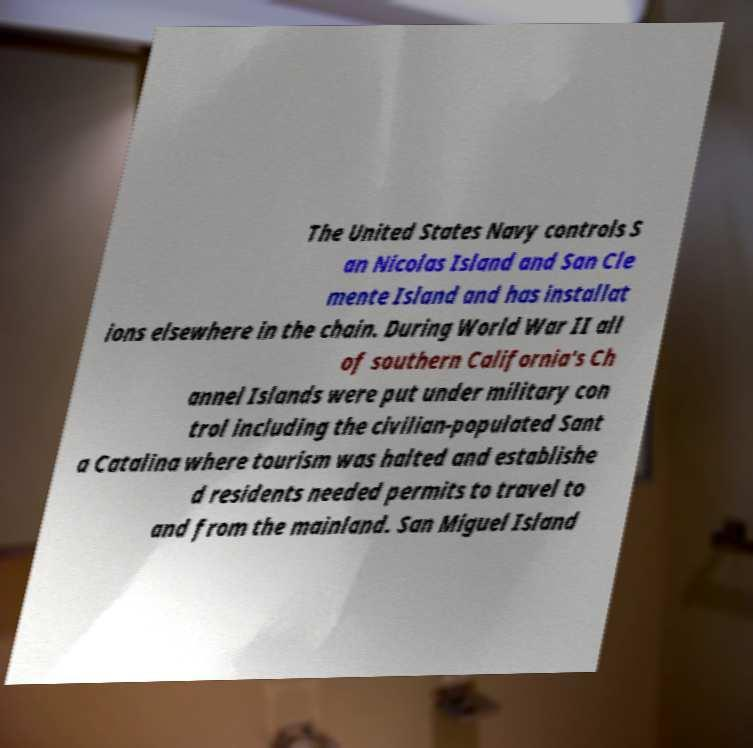Please read and relay the text visible in this image. What does it say? The United States Navy controls S an Nicolas Island and San Cle mente Island and has installat ions elsewhere in the chain. During World War II all of southern California's Ch annel Islands were put under military con trol including the civilian-populated Sant a Catalina where tourism was halted and establishe d residents needed permits to travel to and from the mainland. San Miguel Island 